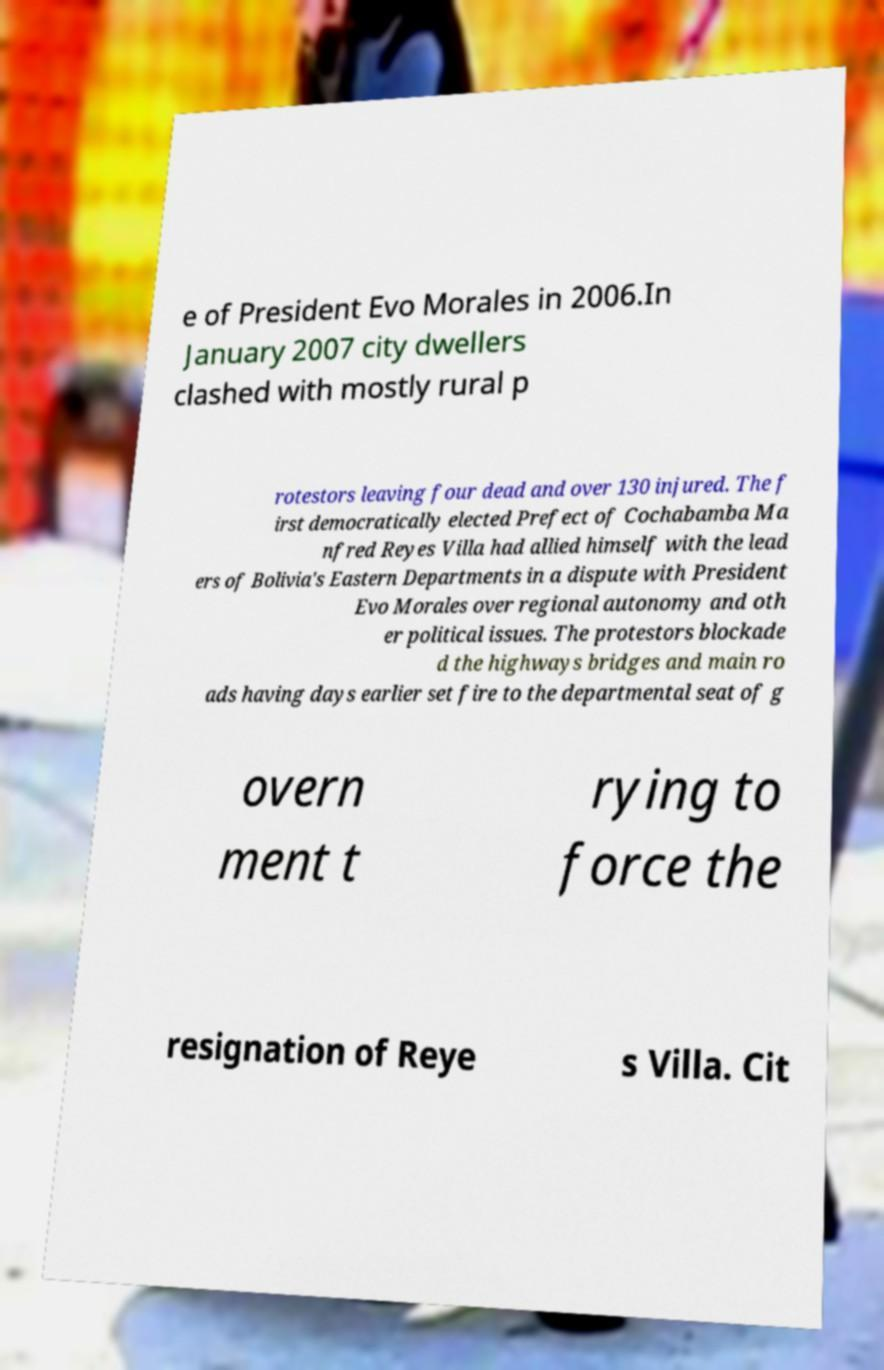Please identify and transcribe the text found in this image. e of President Evo Morales in 2006.In January 2007 city dwellers clashed with mostly rural p rotestors leaving four dead and over 130 injured. The f irst democratically elected Prefect of Cochabamba Ma nfred Reyes Villa had allied himself with the lead ers of Bolivia's Eastern Departments in a dispute with President Evo Morales over regional autonomy and oth er political issues. The protestors blockade d the highways bridges and main ro ads having days earlier set fire to the departmental seat of g overn ment t rying to force the resignation of Reye s Villa. Cit 